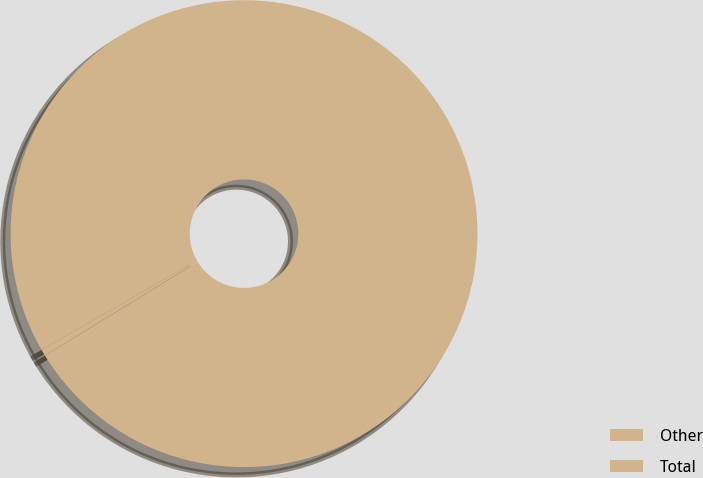Convert chart to OTSL. <chart><loc_0><loc_0><loc_500><loc_500><pie_chart><fcel>Other<fcel>Total<nl><fcel>0.46%<fcel>99.54%<nl></chart> 